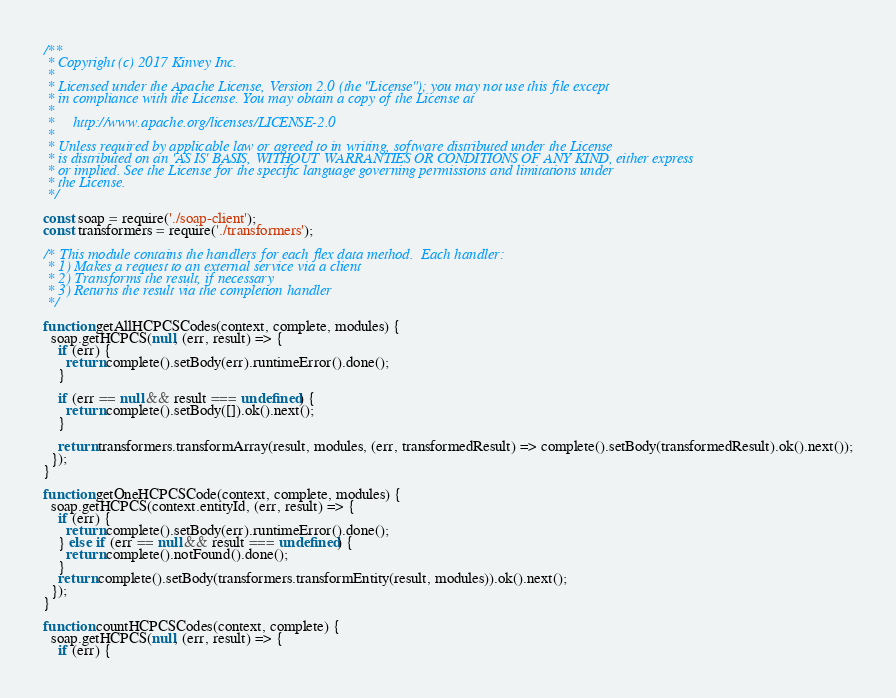Convert code to text. <code><loc_0><loc_0><loc_500><loc_500><_JavaScript_>/**
 * Copyright (c) 2017 Kinvey Inc.
 *
 * Licensed under the Apache License, Version 2.0 (the "License"); you may not use this file except
 * in compliance with the License. You may obtain a copy of the License at
 *
 *     http://www.apache.org/licenses/LICENSE-2.0
 *
 * Unless required by applicable law or agreed to in writing, software distributed under the License
 * is distributed on an 'AS IS' BASIS, WITHOUT WARRANTIES OR CONDITIONS OF ANY KIND, either express
 * or implied. See the License for the specific language governing permissions and limitations under
 * the License.
 */

const soap = require('./soap-client');
const transformers = require('./transformers');

/* This module contains the handlers for each flex data method.  Each handler:
 * 1) Makes a request to an external service via a client
 * 2) Transforms the result, if necessary
 * 3) Returns the result via the completion handler
 */

function getAllHCPCSCodes(context, complete, modules) {
  soap.getHCPCS(null, (err, result) => {
    if (err) {
      return complete().setBody(err).runtimeError().done();
    }

    if (err == null && result === undefined) {
      return complete().setBody([]).ok().next();
    }

    return transformers.transformArray(result, modules, (err, transformedResult) => complete().setBody(transformedResult).ok().next());
  });
}

function getOneHCPCSCode(context, complete, modules) {
  soap.getHCPCS(context.entityId, (err, result) => {
    if (err) {
      return complete().setBody(err).runtimeError().done();
    } else if (err == null && result === undefined) {
      return complete().notFound().done();
    }
    return complete().setBody(transformers.transformEntity(result, modules)).ok().next();
  });
}

function countHCPCSCodes(context, complete) {
  soap.getHCPCS(null, (err, result) => {
    if (err) {</code> 